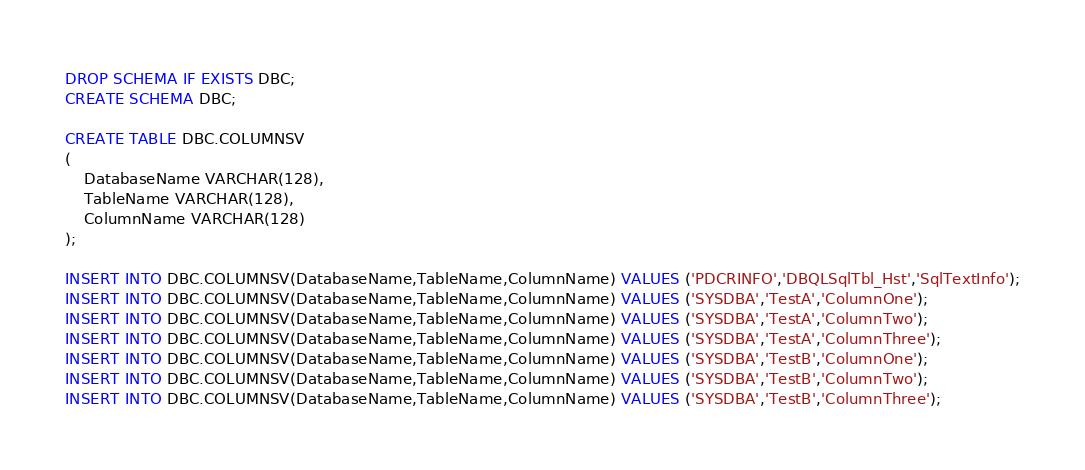<code> <loc_0><loc_0><loc_500><loc_500><_SQL_>DROP SCHEMA IF EXISTS DBC;
CREATE SCHEMA DBC;

CREATE TABLE DBC.COLUMNSV
(
    DatabaseName VARCHAR(128),
    TableName VARCHAR(128),
    ColumnName VARCHAR(128)
);

INSERT INTO DBC.COLUMNSV(DatabaseName,TableName,ColumnName) VALUES ('PDCRINFO','DBQLSqlTbl_Hst','SqlTextInfo');
INSERT INTO DBC.COLUMNSV(DatabaseName,TableName,ColumnName) VALUES ('SYSDBA','TestA','ColumnOne');
INSERT INTO DBC.COLUMNSV(DatabaseName,TableName,ColumnName) VALUES ('SYSDBA','TestA','ColumnTwo');
INSERT INTO DBC.COLUMNSV(DatabaseName,TableName,ColumnName) VALUES ('SYSDBA','TestA','ColumnThree');
INSERT INTO DBC.COLUMNSV(DatabaseName,TableName,ColumnName) VALUES ('SYSDBA','TestB','ColumnOne');
INSERT INTO DBC.COLUMNSV(DatabaseName,TableName,ColumnName) VALUES ('SYSDBA','TestB','ColumnTwo');
INSERT INTO DBC.COLUMNSV(DatabaseName,TableName,ColumnName) VALUES ('SYSDBA','TestB','ColumnThree');</code> 